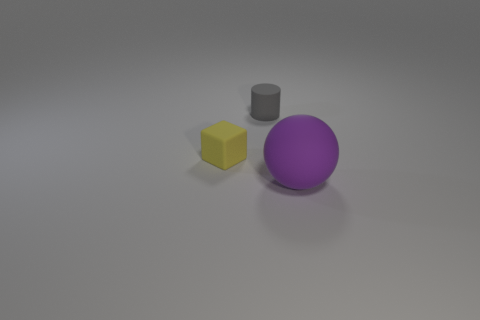Add 1 large red matte cubes. How many objects exist? 4 Subtract all cylinders. How many objects are left? 2 Subtract all large gray balls. Subtract all large purple balls. How many objects are left? 2 Add 3 purple spheres. How many purple spheres are left? 4 Add 3 big rubber things. How many big rubber things exist? 4 Subtract 1 gray cylinders. How many objects are left? 2 